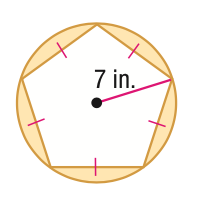Answer the mathemtical geometry problem and directly provide the correct option letter.
Question: Find the area of the shaded region. Round to the nearest tenth.
Choices: A: 7.5 B: 37.4 C: 130.6 D: 270.4 B 